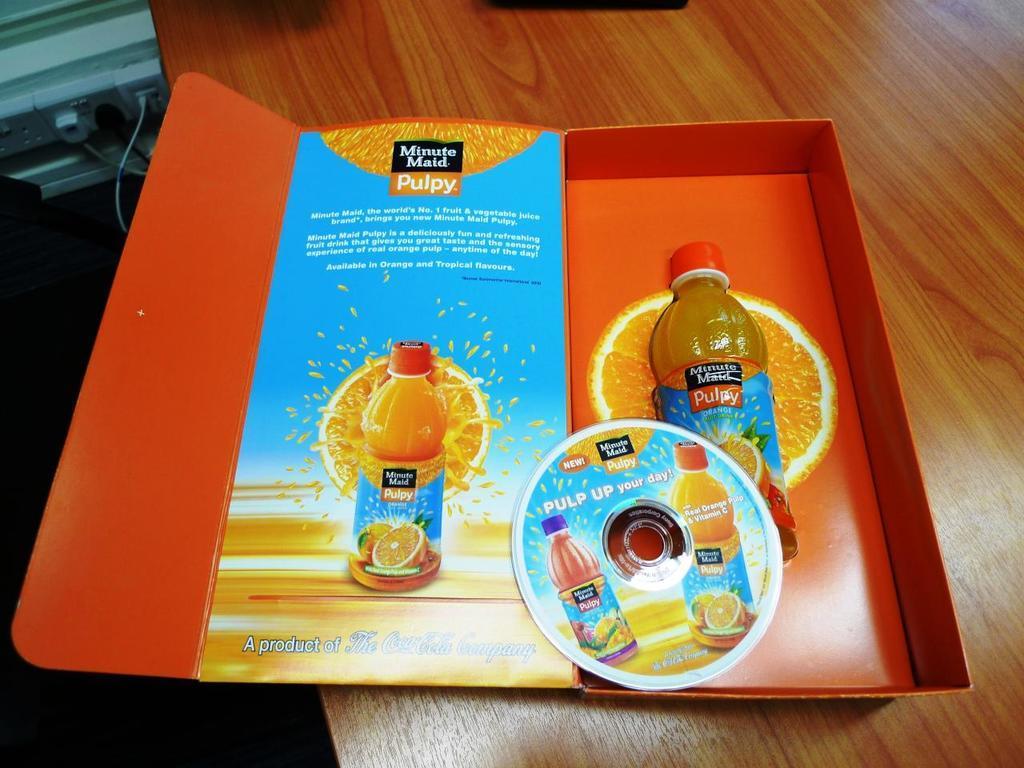Please provide a concise description of this image. This is the picture of the table where we have a minute maid pulpy juice in the box. 